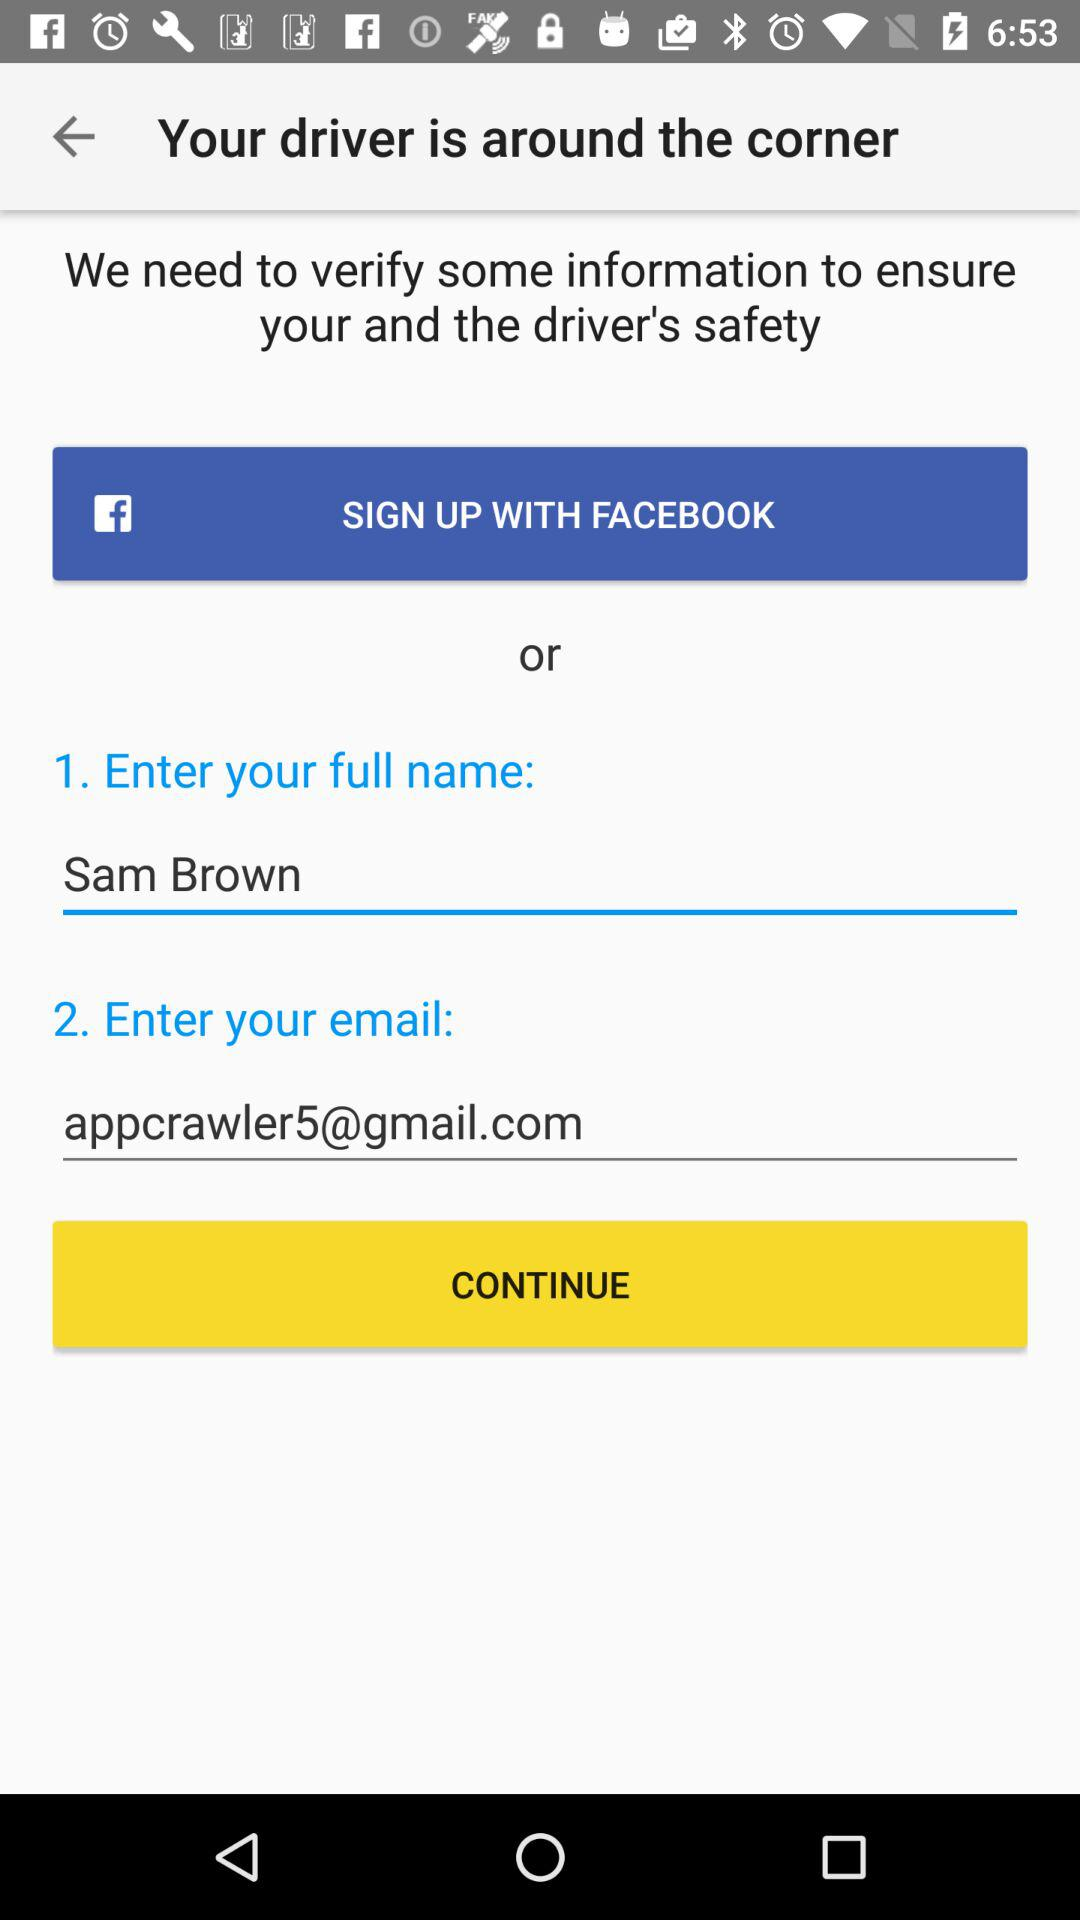What are the different applications through which we can sign up? You can sign up through "FACEBOOK". 